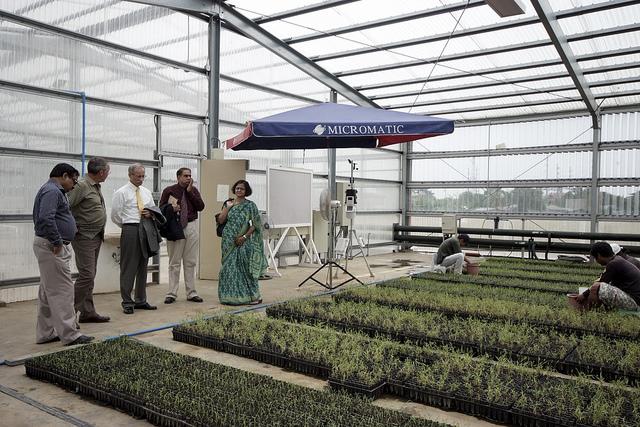How many people are on the landing?
Keep it brief. 5. What sort of plants are these?
Be succinct. Micromatic. Where are the pedestrians walking?
Answer briefly. Greenhouse. What is written on the umbrella?
Quick response, please. Micromatic. What kind of facility are the people standing in?
Give a very brief answer. Greenhouse. 